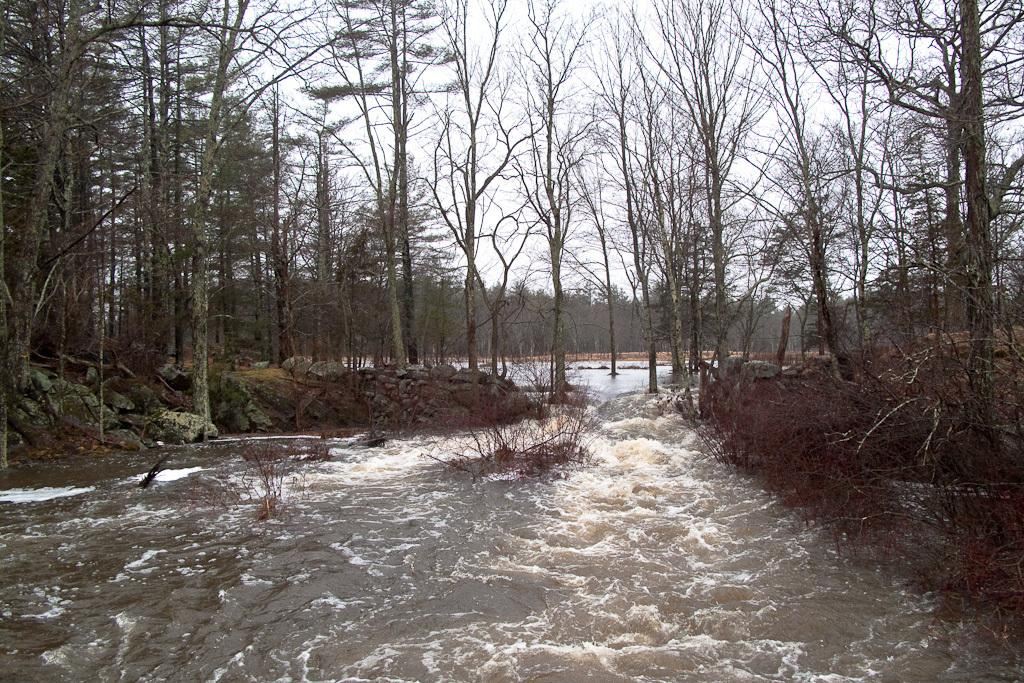What type of vegetation can be seen in the image? There are trees, plants, and grass in the image. What natural features are present in the image? There are rocks and a river in the image. What part of the natural environment is visible in the image? The sky is visible in the image. What type of silk can be seen draped over the plants in the image? There is no silk present in the image; it features trees, plants, grass, rocks, a river, and the sky. 